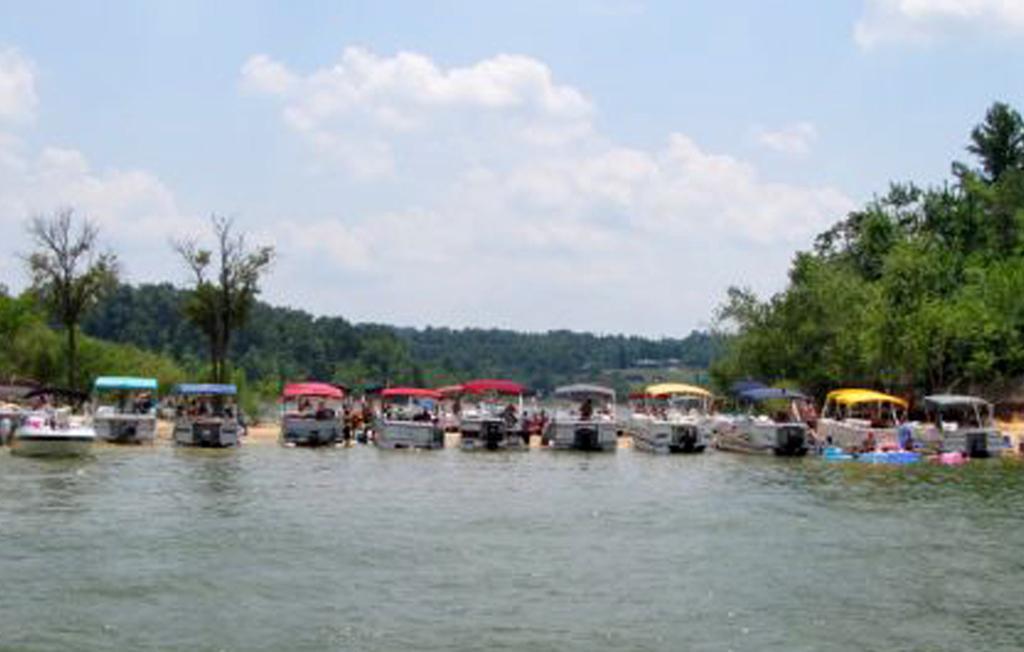Describe this image in one or two sentences. In this image I can see few boats on the water and I can see few persons sitting in the boat. Background I can see trees in green color and the sky is in white and blue color. 